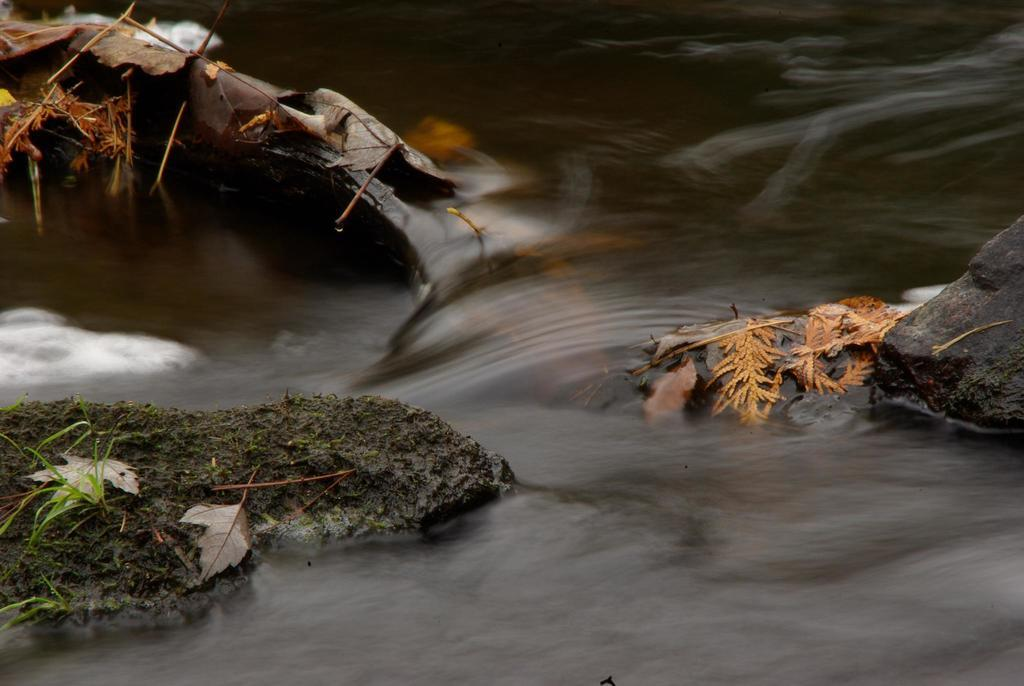What is happening in the image? Water is flowing in the image. What is the water flowing between? The water is flowing between rocks. What can be seen on the rocks? Leaves, grass, and stems are present on the rocks. How many women are biting the stems in the image? There are no women or biting actions present in the image; it features water flowing between rocks with leaves, grass, and stems. What type of beast can be seen lurking behind the rocks in the image? There is no beast present in the image; it only shows water flowing between rocks with leaves, grass, and stems. 